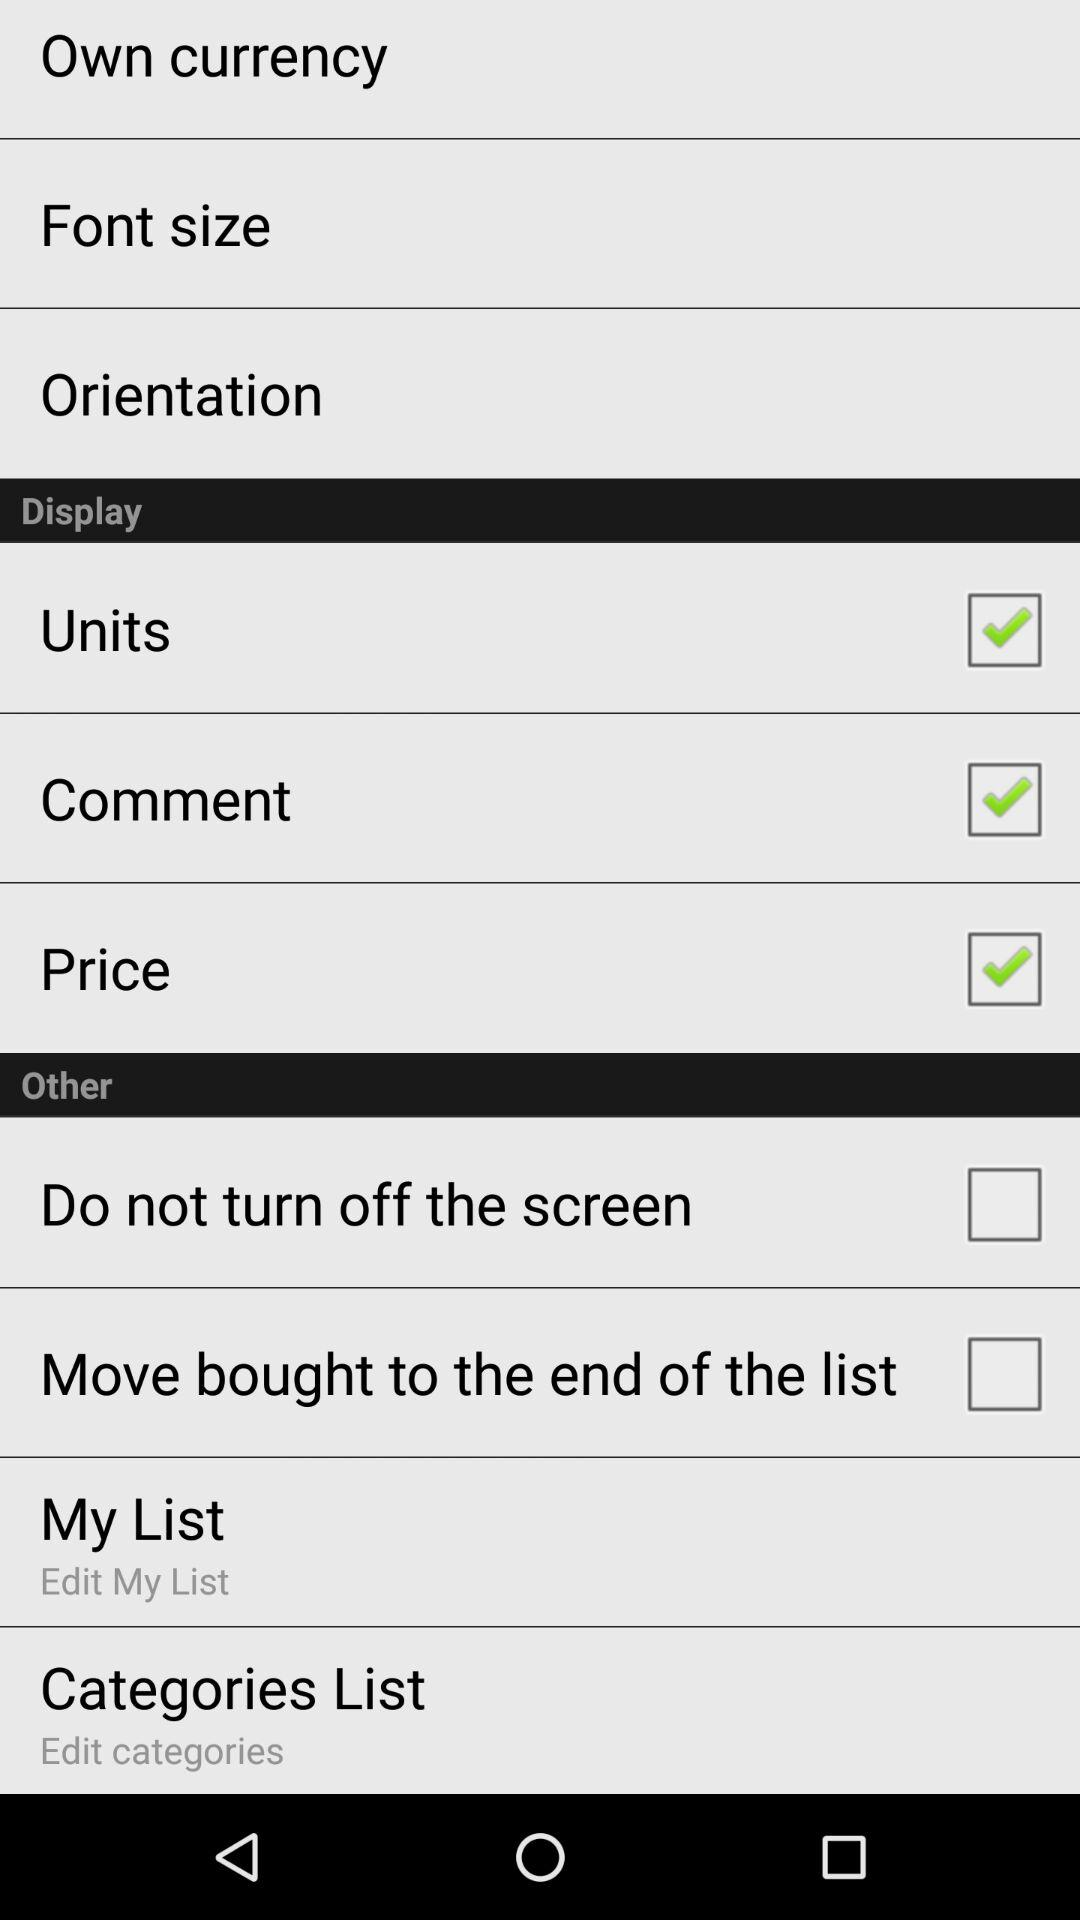What is the status of the price? The status is on. 